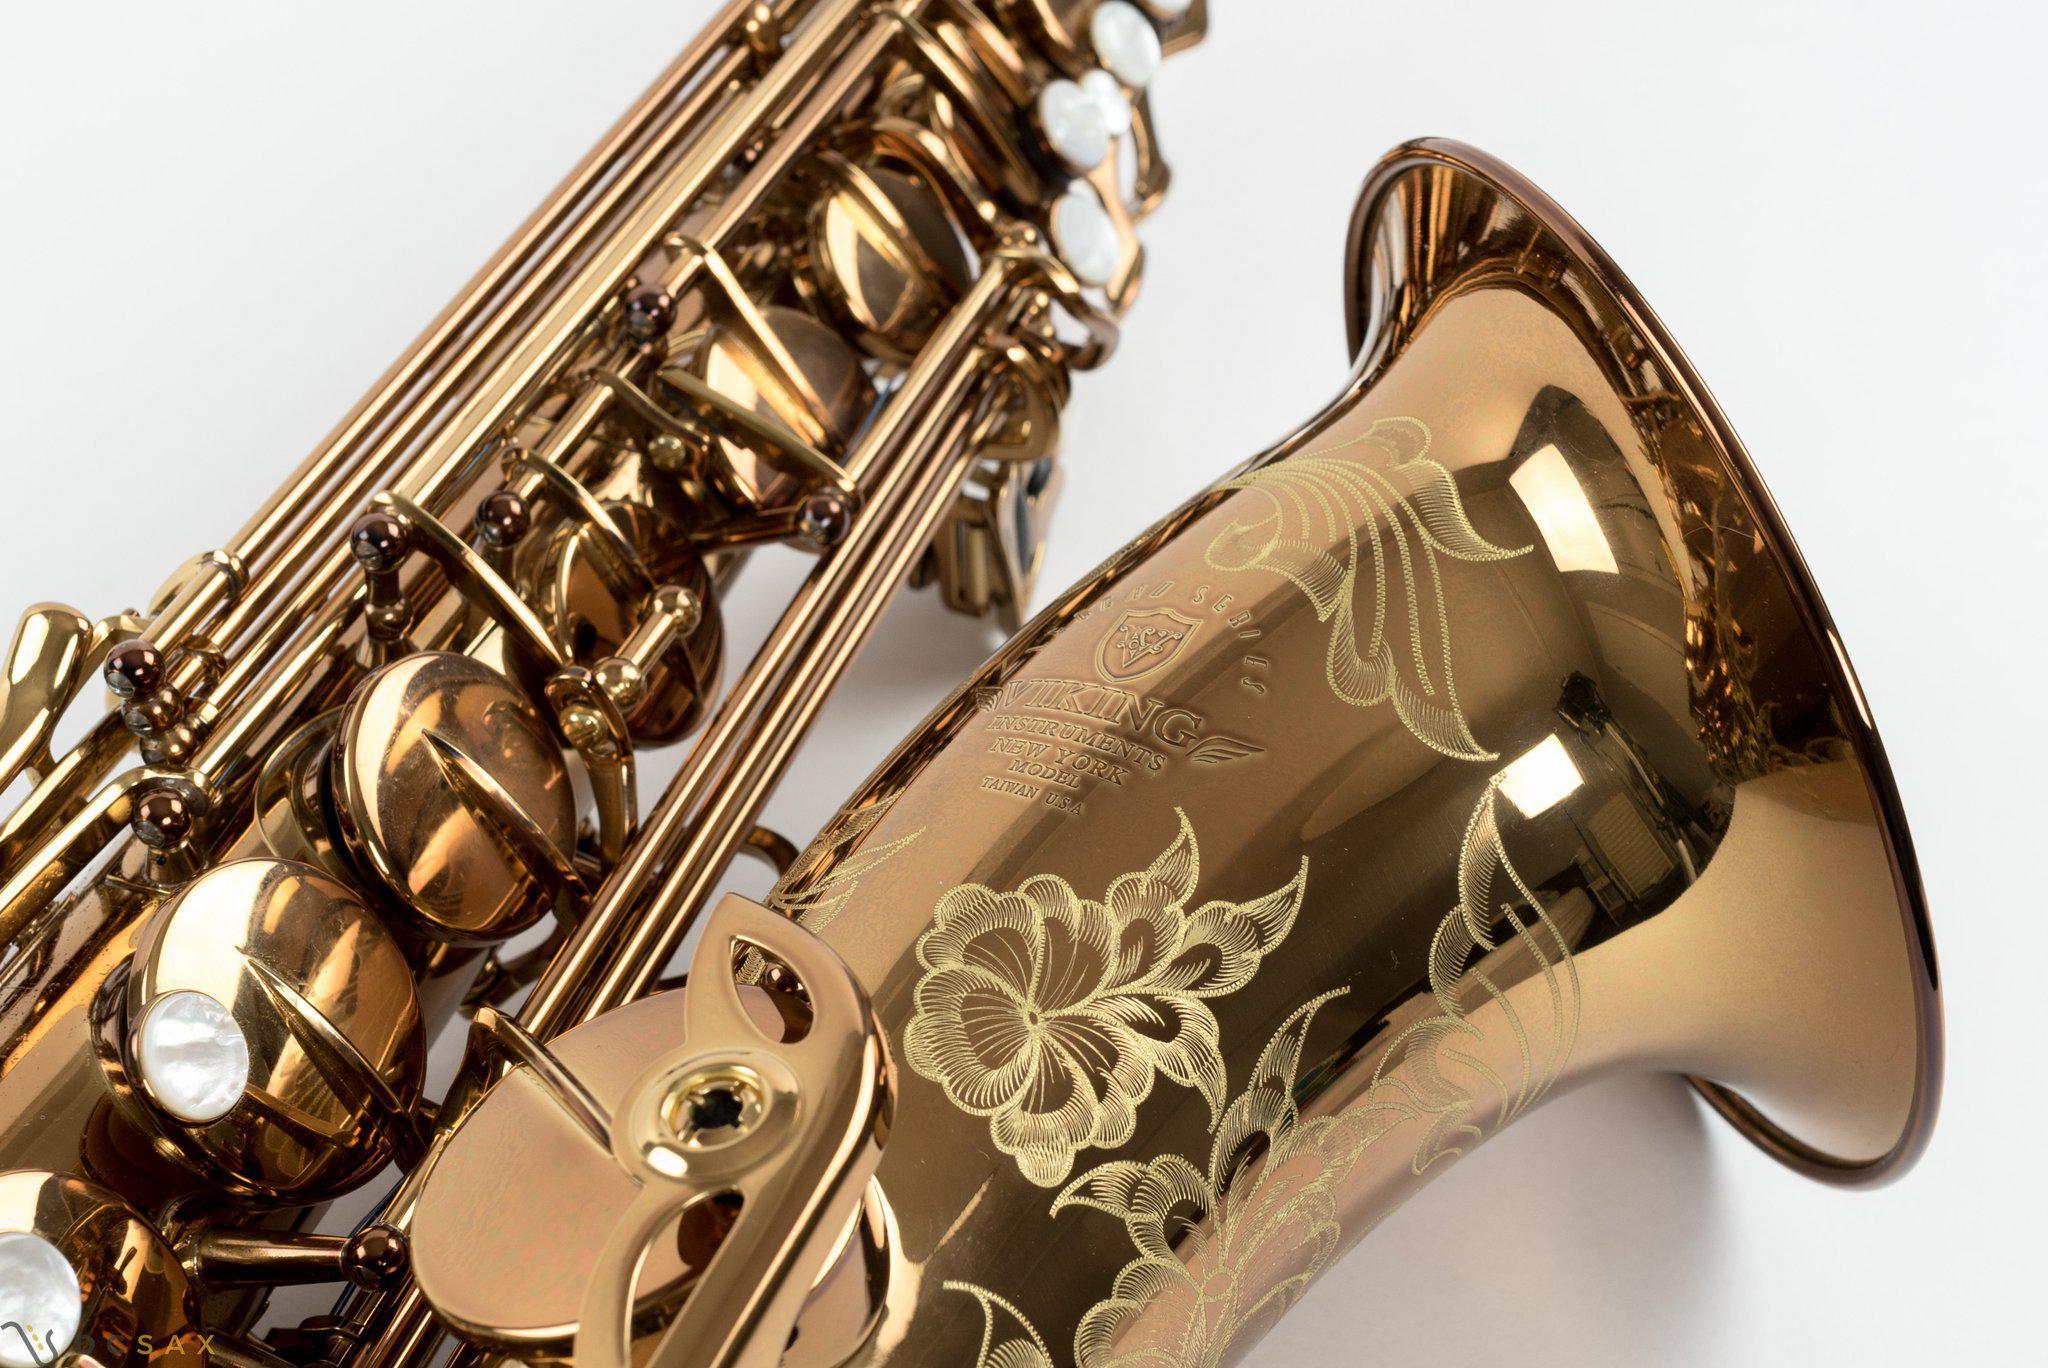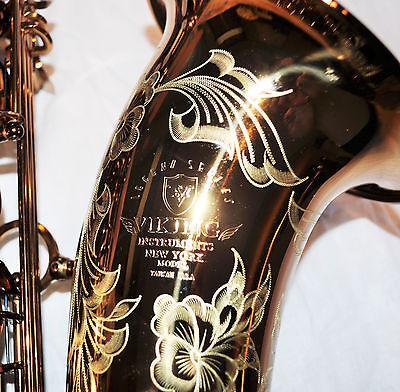The first image is the image on the left, the second image is the image on the right. Evaluate the accuracy of this statement regarding the images: "Each image contains an entire saxophone.". Is it true? Answer yes or no. No. 